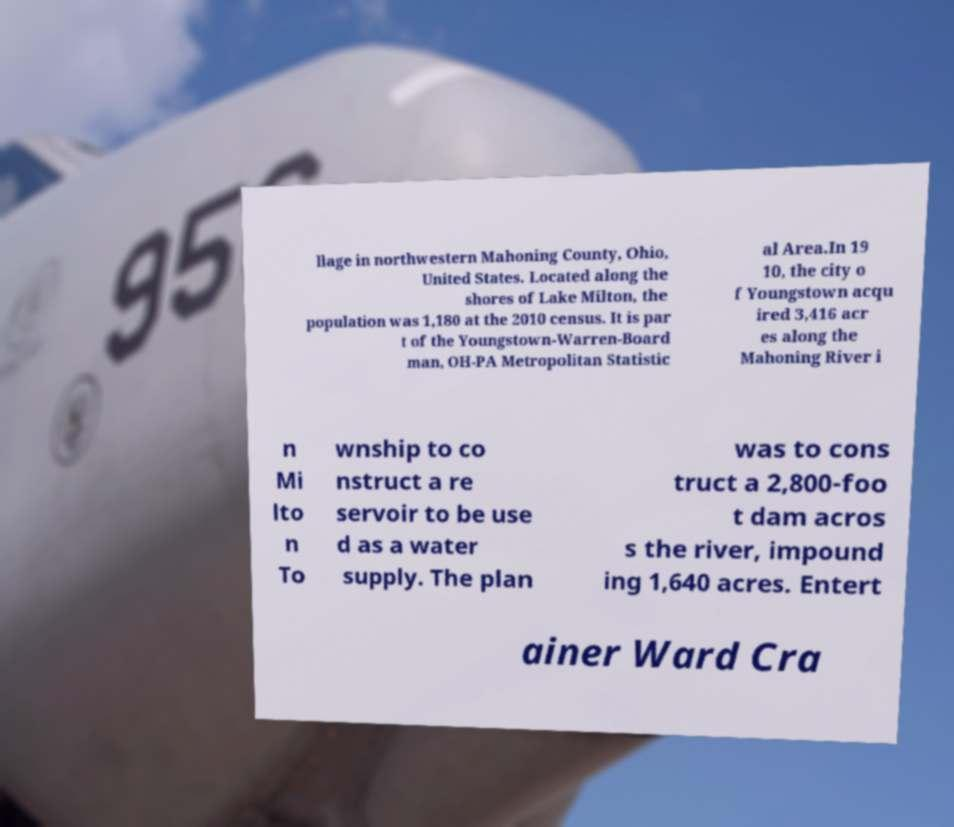There's text embedded in this image that I need extracted. Can you transcribe it verbatim? llage in northwestern Mahoning County, Ohio, United States. Located along the shores of Lake Milton, the population was 1,180 at the 2010 census. It is par t of the Youngstown-Warren-Board man, OH-PA Metropolitan Statistic al Area.In 19 10, the city o f Youngstown acqu ired 3,416 acr es along the Mahoning River i n Mi lto n To wnship to co nstruct a re servoir to be use d as a water supply. The plan was to cons truct a 2,800-foo t dam acros s the river, impound ing 1,640 acres. Entert ainer Ward Cra 